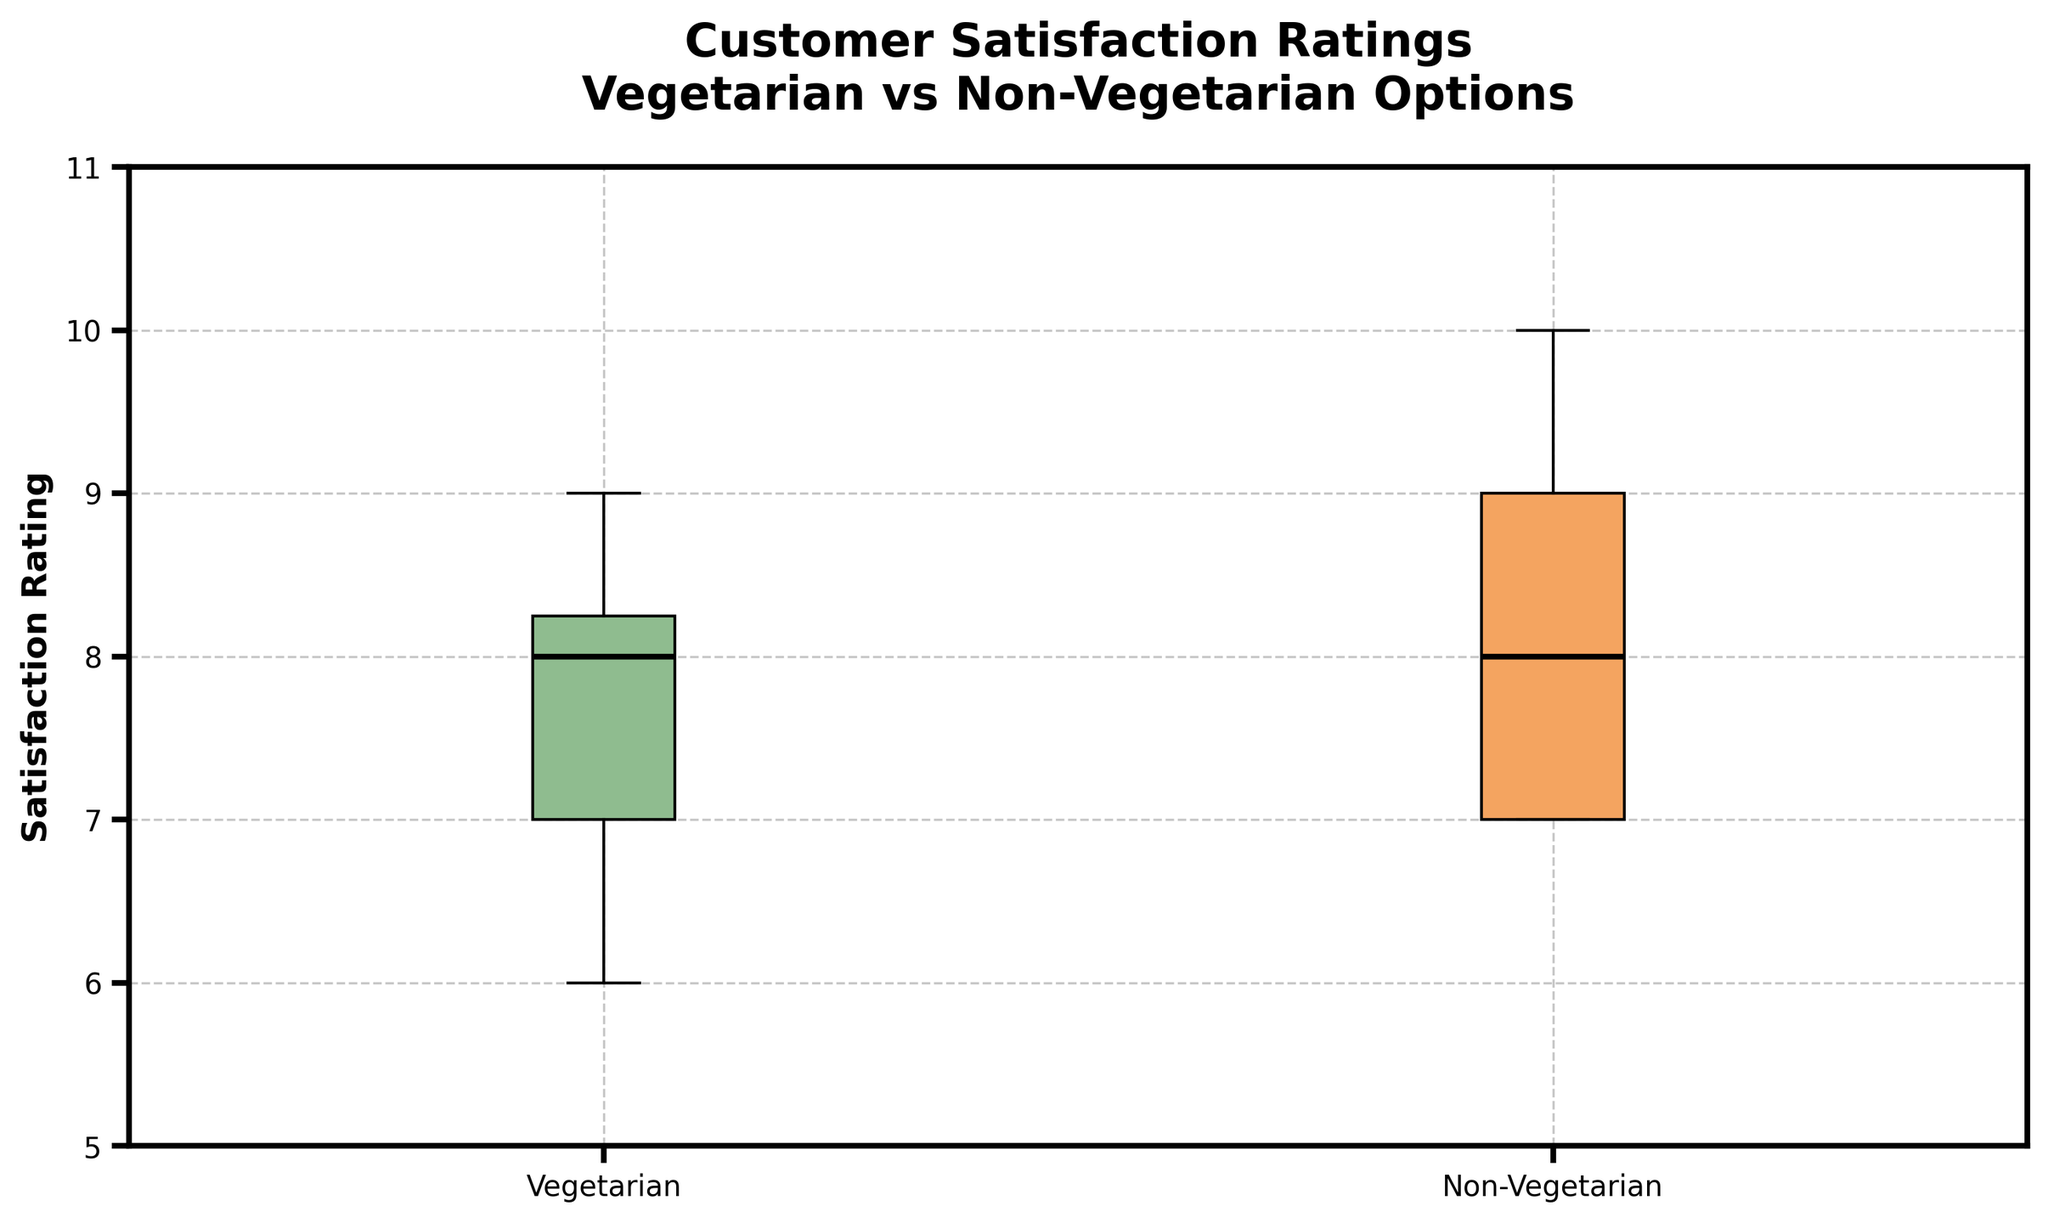What is the title of the figure? The title of the figure is located at the top, which is “Customer Satisfaction Ratings Vegetarian vs Non-Vegetarian Options.”
Answer: Customer Satisfaction Ratings Vegetarian vs Non-Vegetarian Options What are the labels on the x-axis? The x-axis labels are at the bottom of the figure and indicate the categories being compared, which are “Vegetarian” and “Non-Vegetarian.”
Answer: Vegetarian, Non-Vegetarian What is the median satisfaction rating for Vegetarian options? The median value for the Vegetarian options is represented by the thick black line within the box. For the Vegetarian options, this line is at the value of 8.
Answer: 8 Which group has a higher median satisfaction rating, Vegetarian or Non-Vegetarian? By comparing the thick black lines (medians) within the boxes for both groups, the Non-Vegetarian group has a median satisfaction rating at 8.5, while the Vegetarian group has a median of 8.
Answer: Non-Vegetarian What is the range of satisfaction ratings for the Non-Vegetarian options? The range is found by subtracting the minimum value from the maximum value within the Non-Vegetarian group. The whiskers extend from 7 to 10: Max is 10, Min is 7, so 10 - 7 = 3.
Answer: 3 What is the interquartile range (IQR) for the Vegetarian options? The IQR is the range between the 25th percentile (lower quartile) and the 75th percentile (upper quartile) of the data. For the Vegetarian options, the lower quartile is 7, and the upper quartile is 9; thus, IQR = 9 - 7 = 2.
Answer: 2 How many outliers are there in the figure? Outliers are marked as individual points outside the whiskers. There are no individual points marked outside the whiskers in either category.
Answer: 0 Compare the spread (variance) of satisfaction ratings between Vegetarian and Non-Vegetarian options. The spread (variance) can be visually assessed by the length of the boxes and whiskers. The Non-Vegetarian group has a narrower IQR compared to the Vegetarian group, indicating lower variance.
Answer: Non-Vegetarian has less variance Which group has the higher maximum satisfaction rating? The maximum satisfaction rating is indicated by the upper whisker. The non-vegetarian group has a higher maximum rating at 10 compared to the vegetarian group at 9.
Answer: Non-Vegetarian 